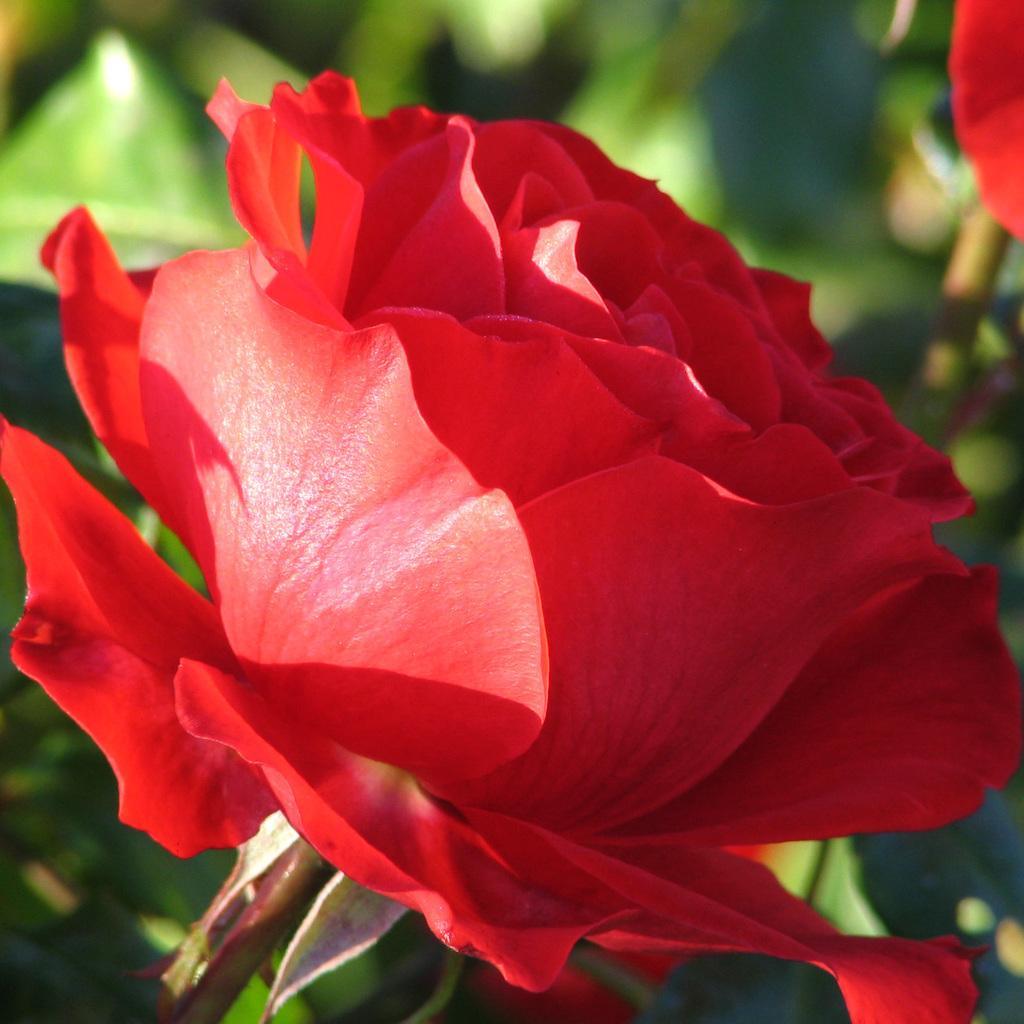Describe this image in one or two sentences. In this image in the middle, there is a red rose. In the background there are plants and rose. 